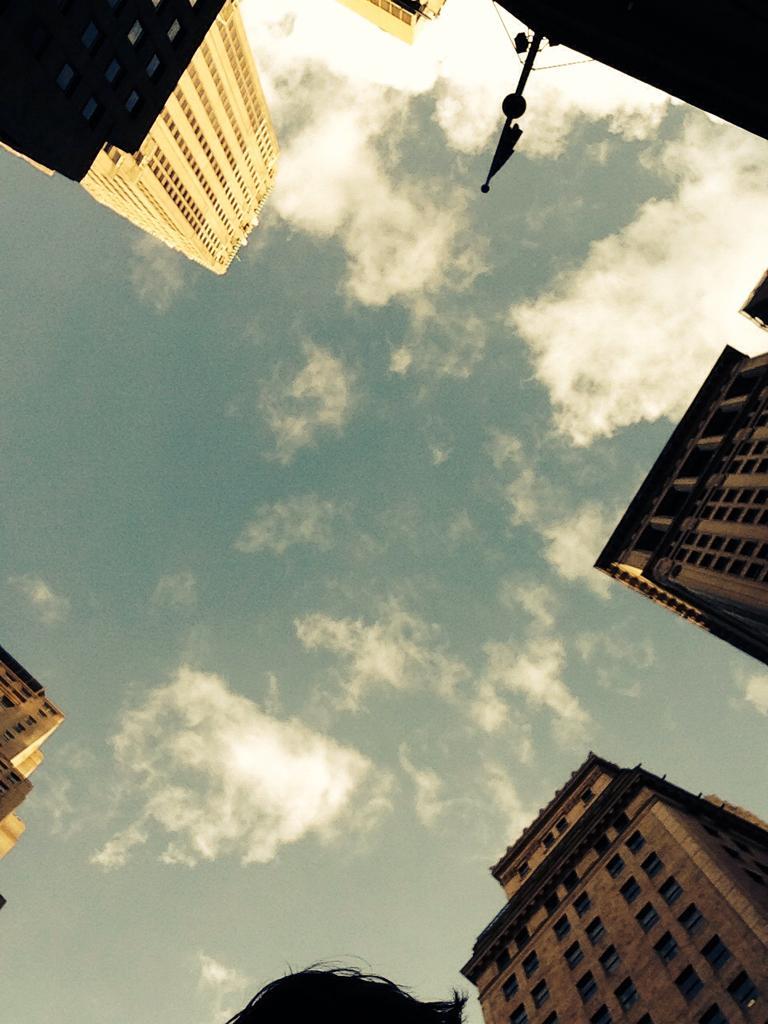How would you summarize this image in a sentence or two? In this image I can see buildings. Here I can also see a pole. Here I can see the sky. 